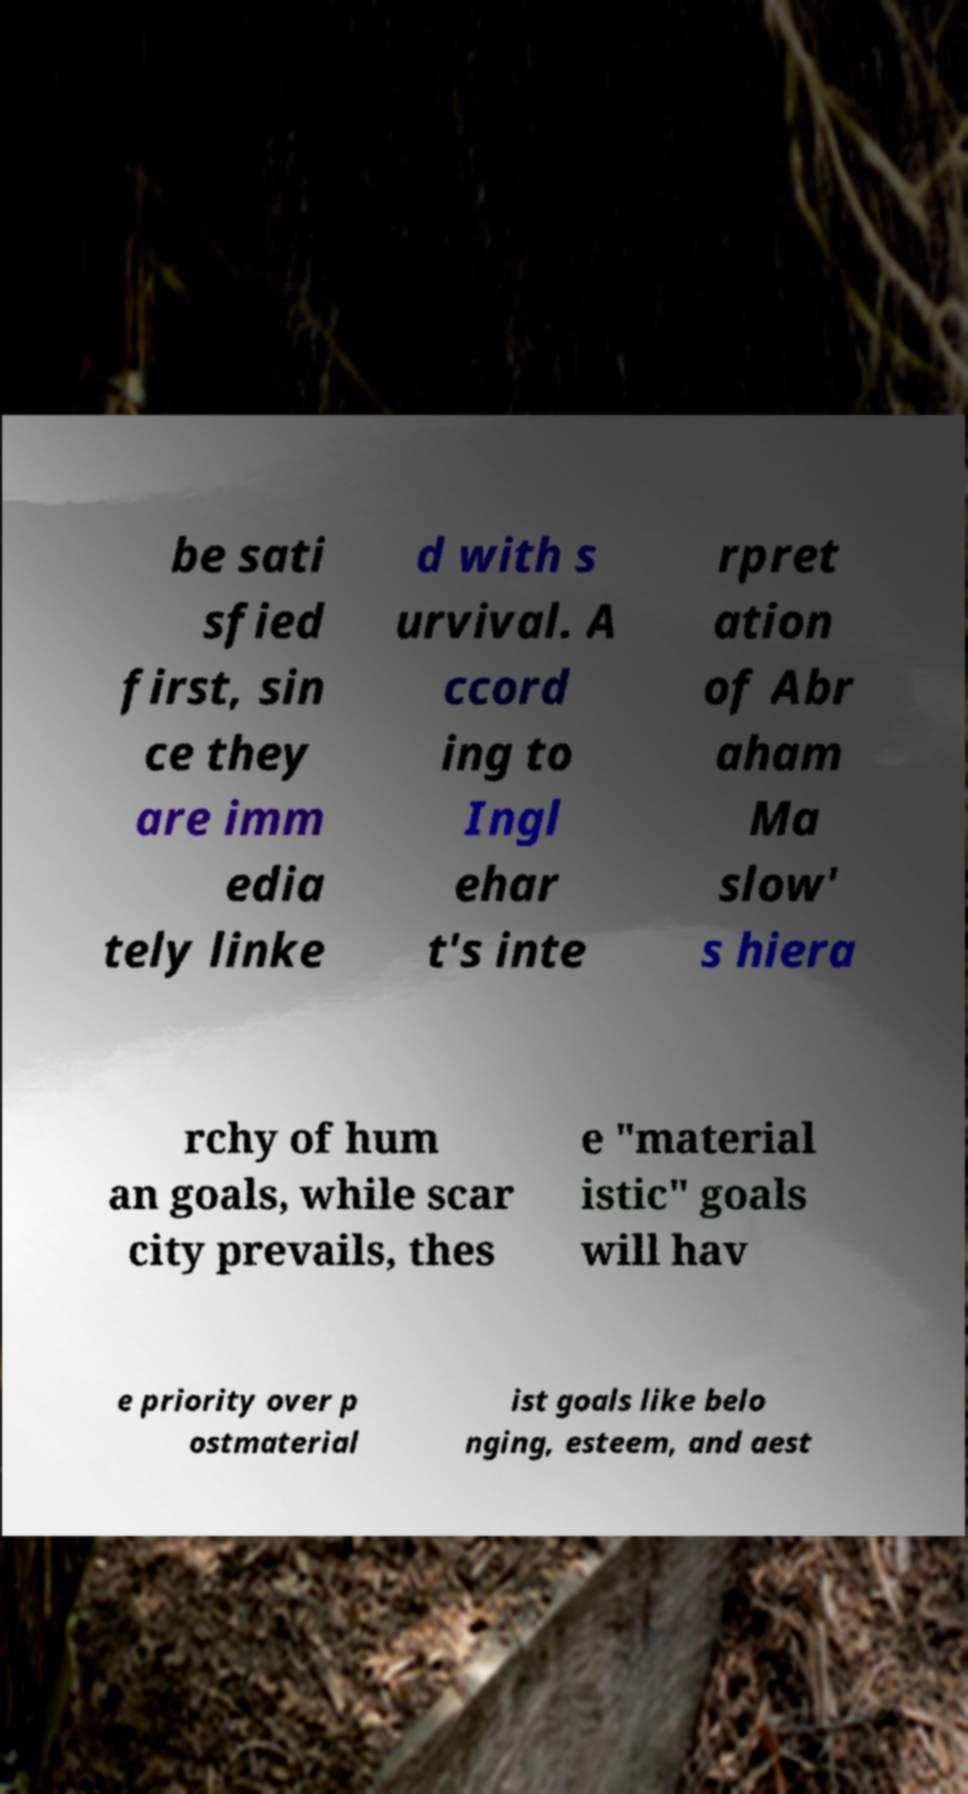Please read and relay the text visible in this image. What does it say? be sati sfied first, sin ce they are imm edia tely linke d with s urvival. A ccord ing to Ingl ehar t's inte rpret ation of Abr aham Ma slow' s hiera rchy of hum an goals, while scar city prevails, thes e "material istic" goals will hav e priority over p ostmaterial ist goals like belo nging, esteem, and aest 